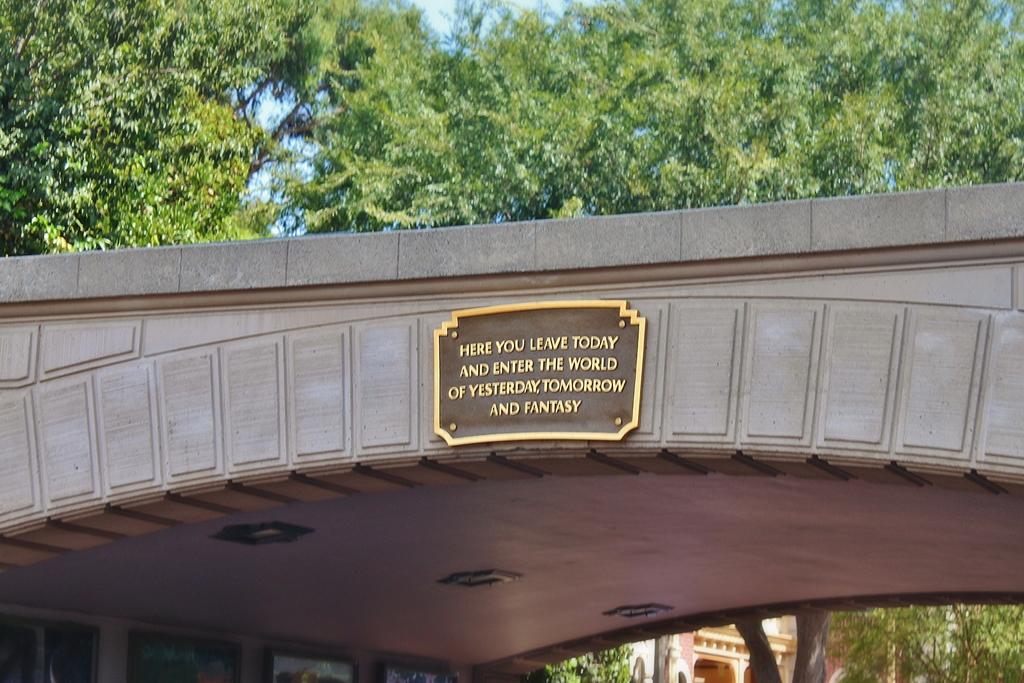You leave today and enter the world of yesterday, tomorrow, and what?
Offer a terse response. Fantasy. 